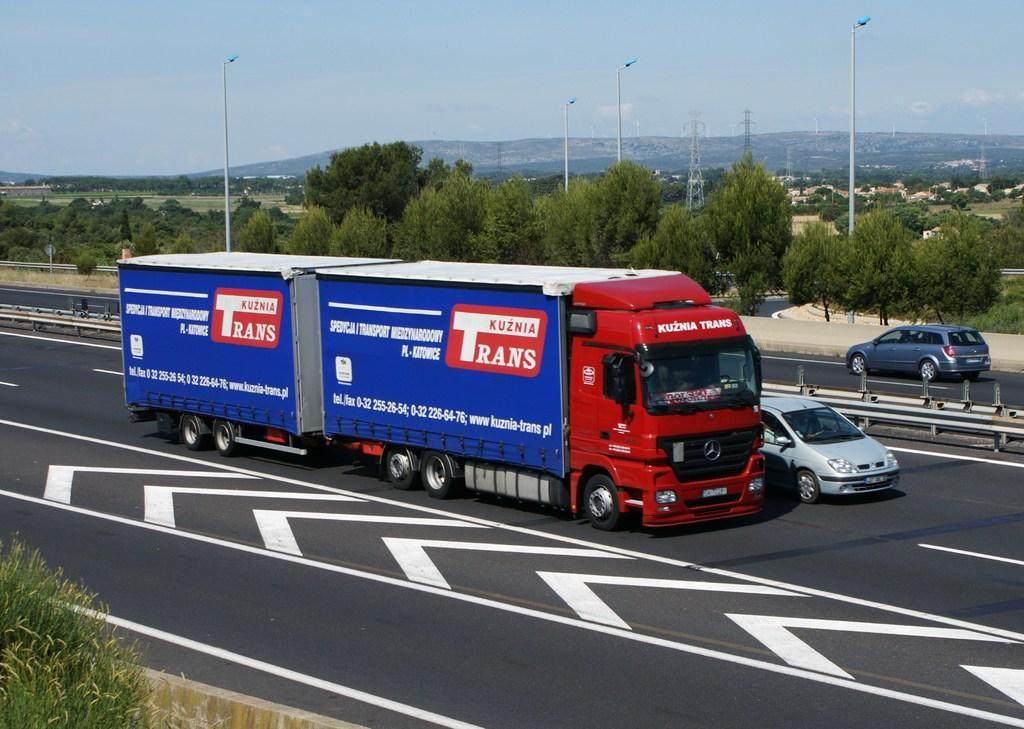What can be seen on the road in the image? There are vehicles on the road in the image. What type of natural elements are visible in the image? There are trees visible in the image. What type of toad can be seen crossing the road in the image? There is no toad present in the image; it only features vehicles on the road and trees. What type of beef dish is being served at the restaurant in the image? There is no restaurant or beef dish present in the image. 